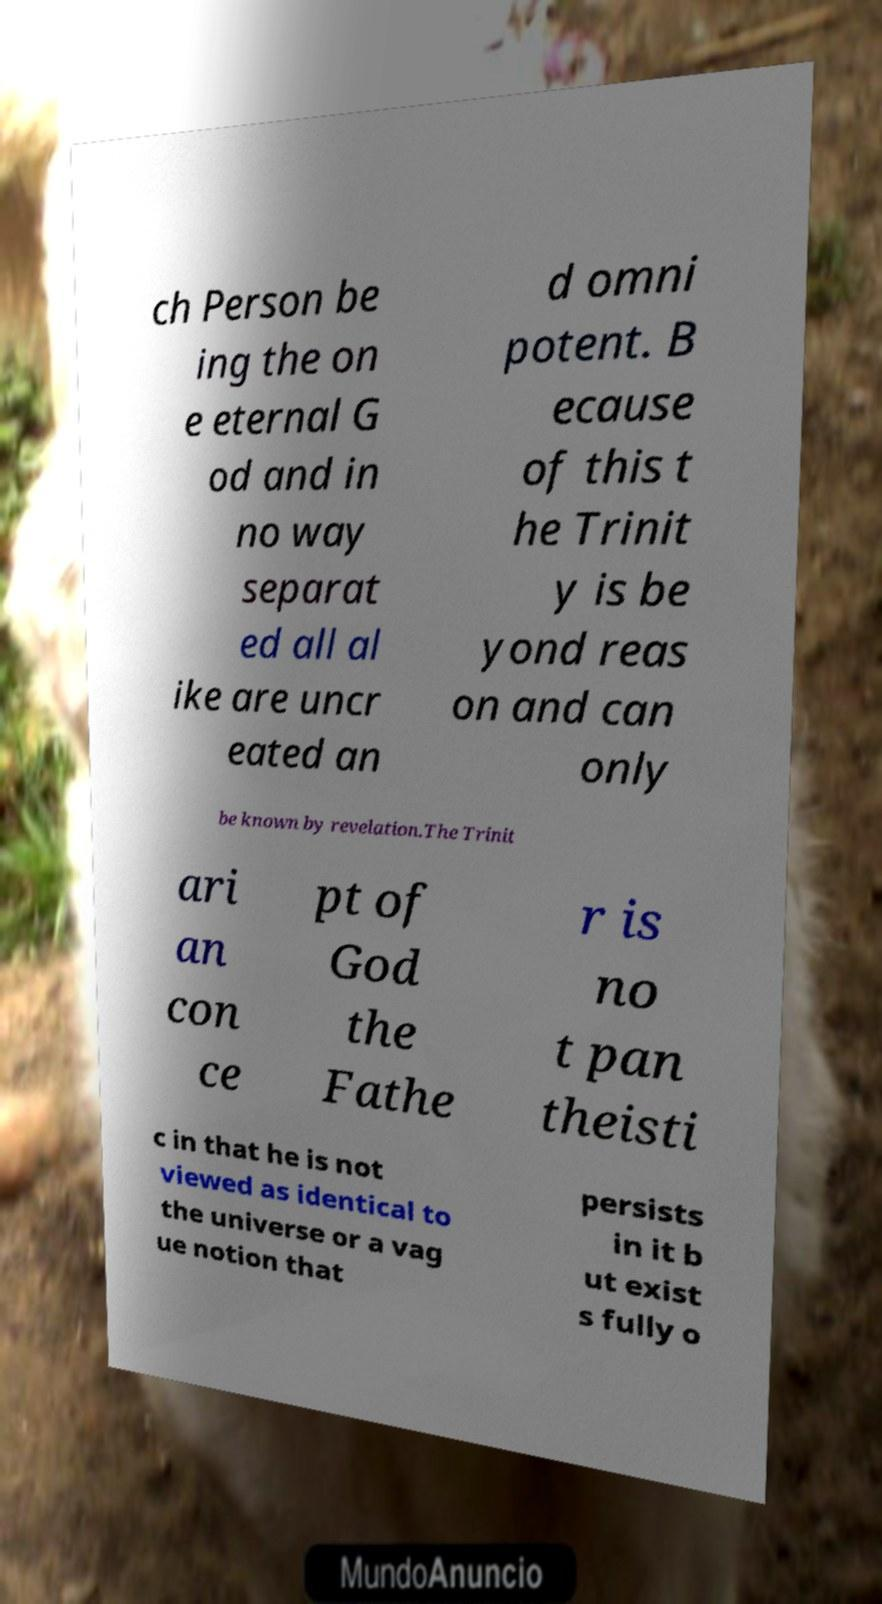There's text embedded in this image that I need extracted. Can you transcribe it verbatim? ch Person be ing the on e eternal G od and in no way separat ed all al ike are uncr eated an d omni potent. B ecause of this t he Trinit y is be yond reas on and can only be known by revelation.The Trinit ari an con ce pt of God the Fathe r is no t pan theisti c in that he is not viewed as identical to the universe or a vag ue notion that persists in it b ut exist s fully o 